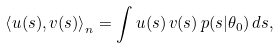Convert formula to latex. <formula><loc_0><loc_0><loc_500><loc_500>\left \langle u ( s ) , v ( s ) \right \rangle _ { n } = \int u ( s ) \, v ( s ) \, p ( s | \theta _ { 0 } ) \, d s ,</formula> 